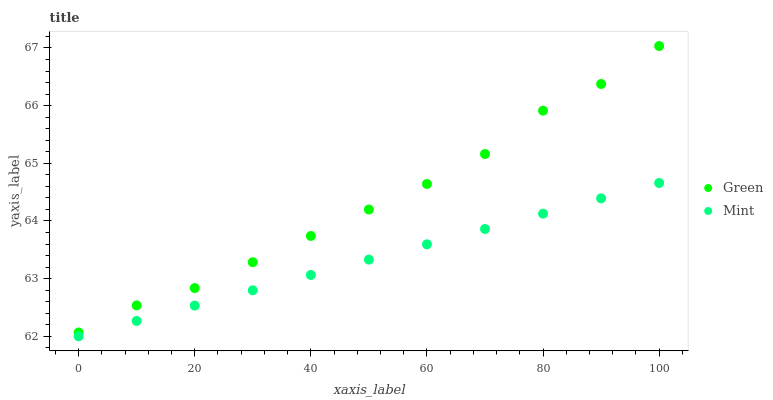Does Mint have the minimum area under the curve?
Answer yes or no. Yes. Does Green have the maximum area under the curve?
Answer yes or no. Yes. Does Green have the minimum area under the curve?
Answer yes or no. No. Is Mint the smoothest?
Answer yes or no. Yes. Is Green the roughest?
Answer yes or no. Yes. Is Green the smoothest?
Answer yes or no. No. Does Mint have the lowest value?
Answer yes or no. Yes. Does Green have the lowest value?
Answer yes or no. No. Does Green have the highest value?
Answer yes or no. Yes. Is Mint less than Green?
Answer yes or no. Yes. Is Green greater than Mint?
Answer yes or no. Yes. Does Mint intersect Green?
Answer yes or no. No. 